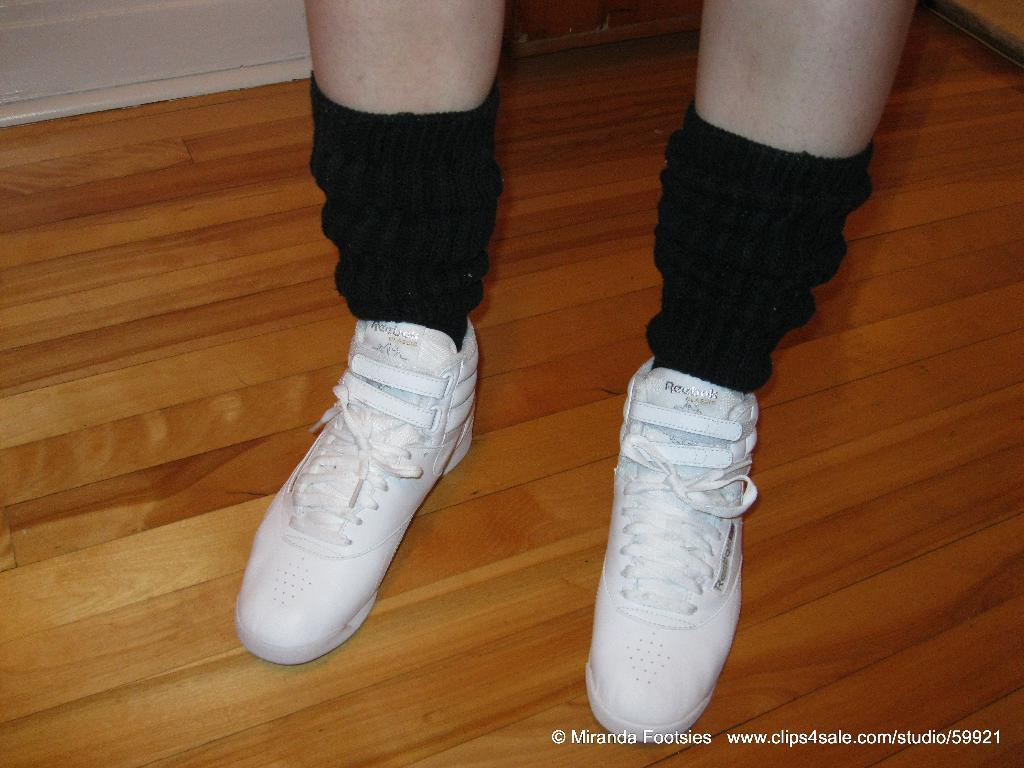What part of a person can be seen in the image? There are legs of a person visible in the image. What type of socks is the person wearing? The person is wearing black color socks. What type of shoes is the person wearing? The person is wearing white shoes. Where is the watermark located in the image? The watermark is on the bottom right side of the image. What time of day is depicted in the image? The image does not show any indication of the time of day, so it cannot be determined from the image. 